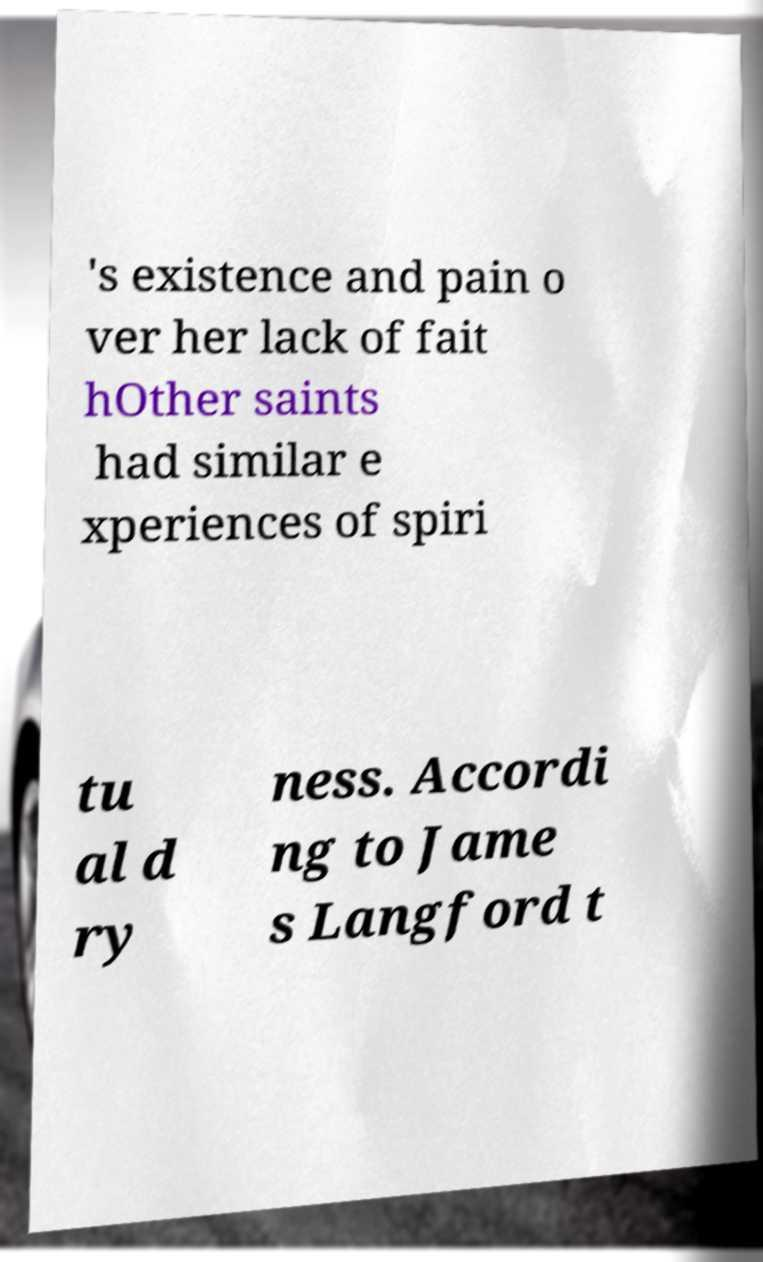There's text embedded in this image that I need extracted. Can you transcribe it verbatim? 's existence and pain o ver her lack of fait hOther saints had similar e xperiences of spiri tu al d ry ness. Accordi ng to Jame s Langford t 